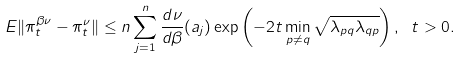Convert formula to latex. <formula><loc_0><loc_0><loc_500><loc_500>E \| \pi ^ { \beta \nu } _ { t } - \pi ^ { \nu } _ { t } \| \leq n \sum _ { j = 1 } ^ { n } \frac { d \nu } { d \beta } ( a _ { j } ) \exp \left ( - 2 t \min _ { p \ne q } \sqrt { \lambda _ { p q } \lambda _ { q p } } \right ) , \ t > 0 .</formula> 